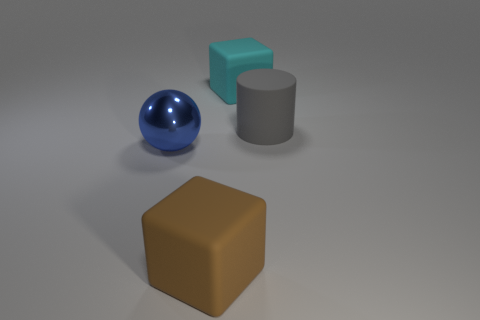What is the material of the large blue object?
Offer a very short reply. Metal. How many shiny objects are either gray cylinders or small cyan cubes?
Your answer should be very brief. 0. Are there fewer cyan objects that are right of the gray cylinder than blue metal things left of the brown matte object?
Ensure brevity in your answer.  Yes. There is a thing to the left of the matte block in front of the big gray object; is there a rubber object that is behind it?
Provide a succinct answer. Yes. There is a thing in front of the large shiny ball; does it have the same shape as the big cyan rubber object that is behind the metal thing?
Give a very brief answer. Yes. What material is the ball that is the same size as the cyan matte block?
Make the answer very short. Metal. Are the block that is in front of the big metallic ball and the big blue ball in front of the large gray cylinder made of the same material?
Offer a very short reply. No. There is a cyan rubber thing that is the same size as the brown object; what is its shape?
Provide a short and direct response. Cube. What number of other objects are the same color as the big shiny thing?
Provide a succinct answer. 0. What is the color of the block behind the big brown rubber block?
Keep it short and to the point. Cyan. 